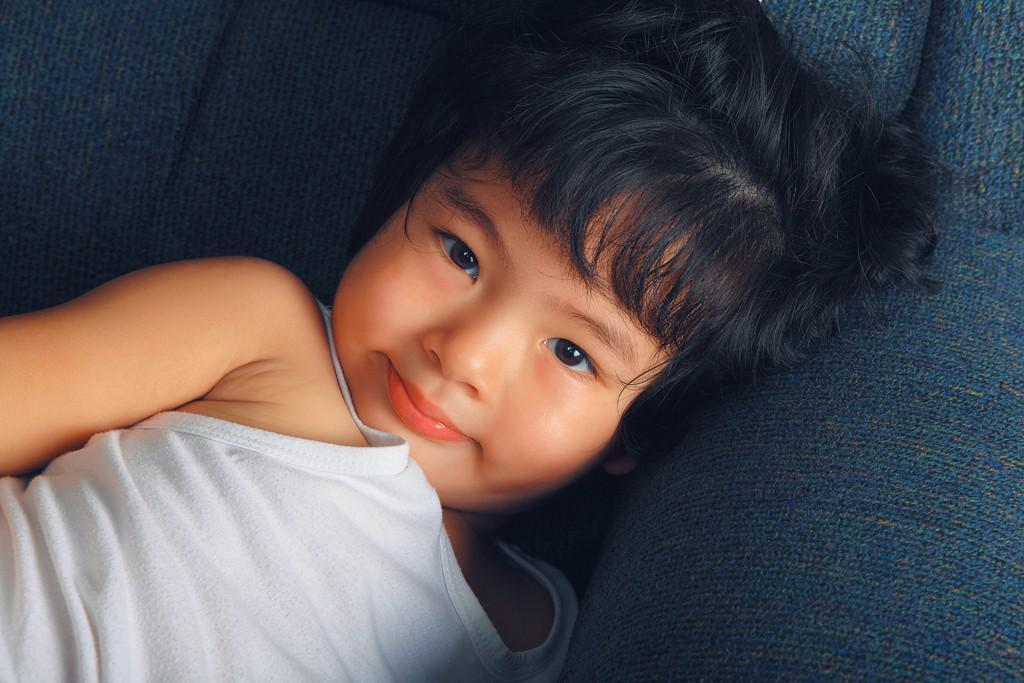Who or what is the main subject in the image? There is a person in the image. What is the person doing in the image? The person is laying on a blue object. What is the person wearing in the image? The person is wearing a white dress. What direction is the tree facing in the image? There is no tree present in the image. What story is the person telling in the image? The image does not depict the person telling a story, so it cannot be determined from the image. 